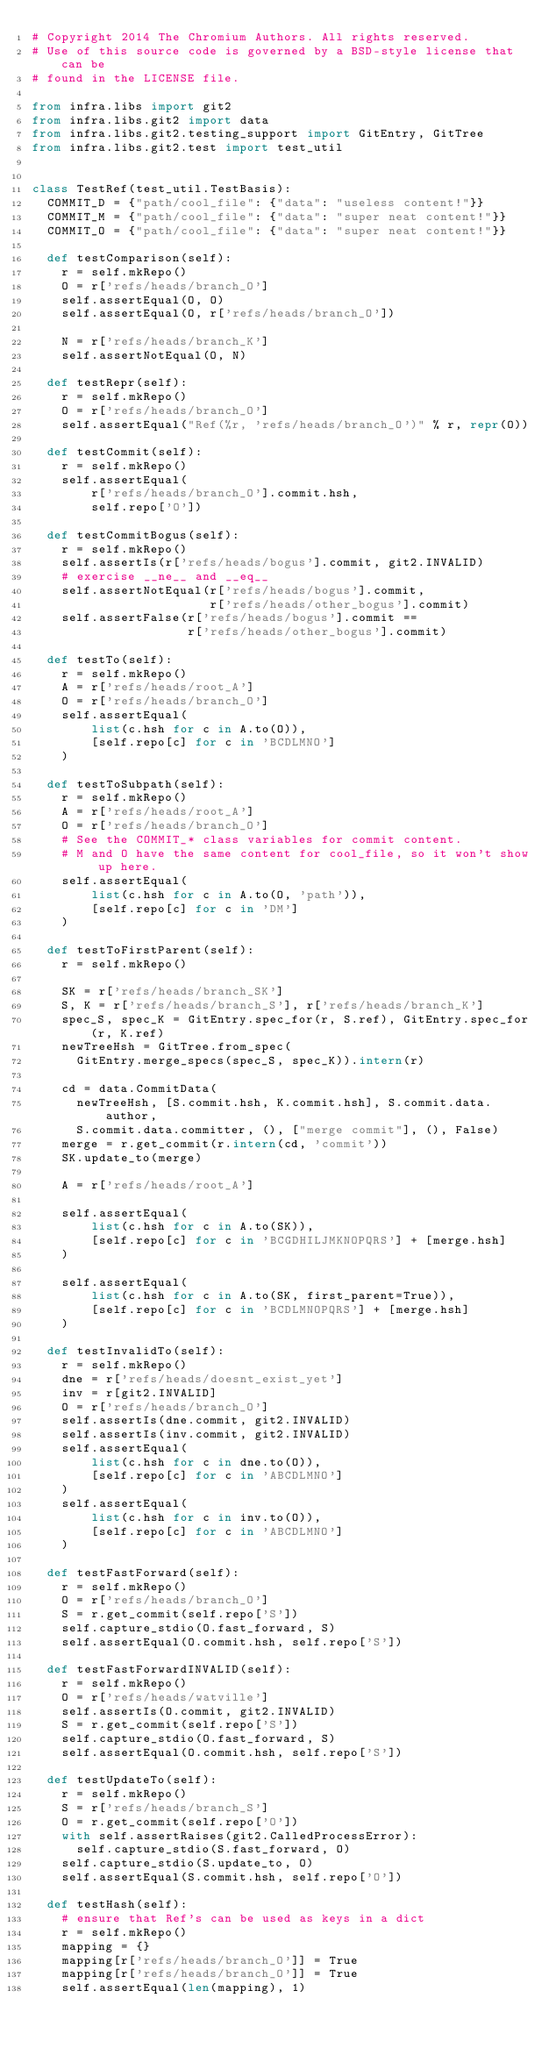<code> <loc_0><loc_0><loc_500><loc_500><_Python_># Copyright 2014 The Chromium Authors. All rights reserved.
# Use of this source code is governed by a BSD-style license that can be
# found in the LICENSE file.

from infra.libs import git2
from infra.libs.git2 import data
from infra.libs.git2.testing_support import GitEntry, GitTree
from infra.libs.git2.test import test_util


class TestRef(test_util.TestBasis):
  COMMIT_D = {"path/cool_file": {"data": "useless content!"}}
  COMMIT_M = {"path/cool_file": {"data": "super neat content!"}}
  COMMIT_O = {"path/cool_file": {"data": "super neat content!"}}

  def testComparison(self):
    r = self.mkRepo()
    O = r['refs/heads/branch_O']
    self.assertEqual(O, O)
    self.assertEqual(O, r['refs/heads/branch_O'])

    N = r['refs/heads/branch_K']
    self.assertNotEqual(O, N)

  def testRepr(self):
    r = self.mkRepo()
    O = r['refs/heads/branch_O']
    self.assertEqual("Ref(%r, 'refs/heads/branch_O')" % r, repr(O))

  def testCommit(self):
    r = self.mkRepo()
    self.assertEqual(
        r['refs/heads/branch_O'].commit.hsh,
        self.repo['O'])

  def testCommitBogus(self):
    r = self.mkRepo()
    self.assertIs(r['refs/heads/bogus'].commit, git2.INVALID)
    # exercise __ne__ and __eq__
    self.assertNotEqual(r['refs/heads/bogus'].commit,
                        r['refs/heads/other_bogus'].commit)
    self.assertFalse(r['refs/heads/bogus'].commit ==
                     r['refs/heads/other_bogus'].commit)

  def testTo(self):
    r = self.mkRepo()
    A = r['refs/heads/root_A']
    O = r['refs/heads/branch_O']
    self.assertEqual(
        list(c.hsh for c in A.to(O)),
        [self.repo[c] for c in 'BCDLMNO']
    )

  def testToSubpath(self):
    r = self.mkRepo()
    A = r['refs/heads/root_A']
    O = r['refs/heads/branch_O']
    # See the COMMIT_* class variables for commit content.
    # M and O have the same content for cool_file, so it won't show up here.
    self.assertEqual(
        list(c.hsh for c in A.to(O, 'path')),
        [self.repo[c] for c in 'DM']
    )

  def testToFirstParent(self):
    r = self.mkRepo()

    SK = r['refs/heads/branch_SK']
    S, K = r['refs/heads/branch_S'], r['refs/heads/branch_K']
    spec_S, spec_K = GitEntry.spec_for(r, S.ref), GitEntry.spec_for(r, K.ref)
    newTreeHsh = GitTree.from_spec(
      GitEntry.merge_specs(spec_S, spec_K)).intern(r)

    cd = data.CommitData(
      newTreeHsh, [S.commit.hsh, K.commit.hsh], S.commit.data.author,
      S.commit.data.committer, (), ["merge commit"], (), False)
    merge = r.get_commit(r.intern(cd, 'commit'))
    SK.update_to(merge)

    A = r['refs/heads/root_A']

    self.assertEqual(
        list(c.hsh for c in A.to(SK)),
        [self.repo[c] for c in 'BCGDHILJMKNOPQRS'] + [merge.hsh]
    )

    self.assertEqual(
        list(c.hsh for c in A.to(SK, first_parent=True)),
        [self.repo[c] for c in 'BCDLMNOPQRS'] + [merge.hsh]
    )

  def testInvalidTo(self):
    r = self.mkRepo()
    dne = r['refs/heads/doesnt_exist_yet']
    inv = r[git2.INVALID]
    O = r['refs/heads/branch_O']
    self.assertIs(dne.commit, git2.INVALID)
    self.assertIs(inv.commit, git2.INVALID)
    self.assertEqual(
        list(c.hsh for c in dne.to(O)),
        [self.repo[c] for c in 'ABCDLMNO']
    )
    self.assertEqual(
        list(c.hsh for c in inv.to(O)),
        [self.repo[c] for c in 'ABCDLMNO']
    )

  def testFastForward(self):
    r = self.mkRepo()
    O = r['refs/heads/branch_O']
    S = r.get_commit(self.repo['S'])
    self.capture_stdio(O.fast_forward, S)
    self.assertEqual(O.commit.hsh, self.repo['S'])

  def testFastForwardINVALID(self):
    r = self.mkRepo()
    O = r['refs/heads/watville']
    self.assertIs(O.commit, git2.INVALID)
    S = r.get_commit(self.repo['S'])
    self.capture_stdio(O.fast_forward, S)
    self.assertEqual(O.commit.hsh, self.repo['S'])

  def testUpdateTo(self):
    r = self.mkRepo()
    S = r['refs/heads/branch_S']
    O = r.get_commit(self.repo['O'])
    with self.assertRaises(git2.CalledProcessError):
      self.capture_stdio(S.fast_forward, O)
    self.capture_stdio(S.update_to, O)
    self.assertEqual(S.commit.hsh, self.repo['O'])

  def testHash(self):
    # ensure that Ref's can be used as keys in a dict
    r = self.mkRepo()
    mapping = {}
    mapping[r['refs/heads/branch_O']] = True
    mapping[r['refs/heads/branch_O']] = True
    self.assertEqual(len(mapping), 1)
</code> 